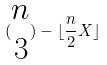<formula> <loc_0><loc_0><loc_500><loc_500>( \begin{matrix} n \\ 3 \end{matrix} ) - \lfloor \frac { n } { 2 } X \rfloor</formula> 